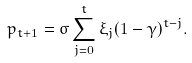<formula> <loc_0><loc_0><loc_500><loc_500>p _ { t + 1 } = \sigma \sum _ { j = 0 } ^ { t } \xi _ { j } ( 1 - \gamma ) ^ { t - j } .</formula> 